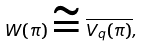<formula> <loc_0><loc_0><loc_500><loc_500>W ( \pi ) \cong \overline { V _ { q } ( \pi ) } ,</formula> 